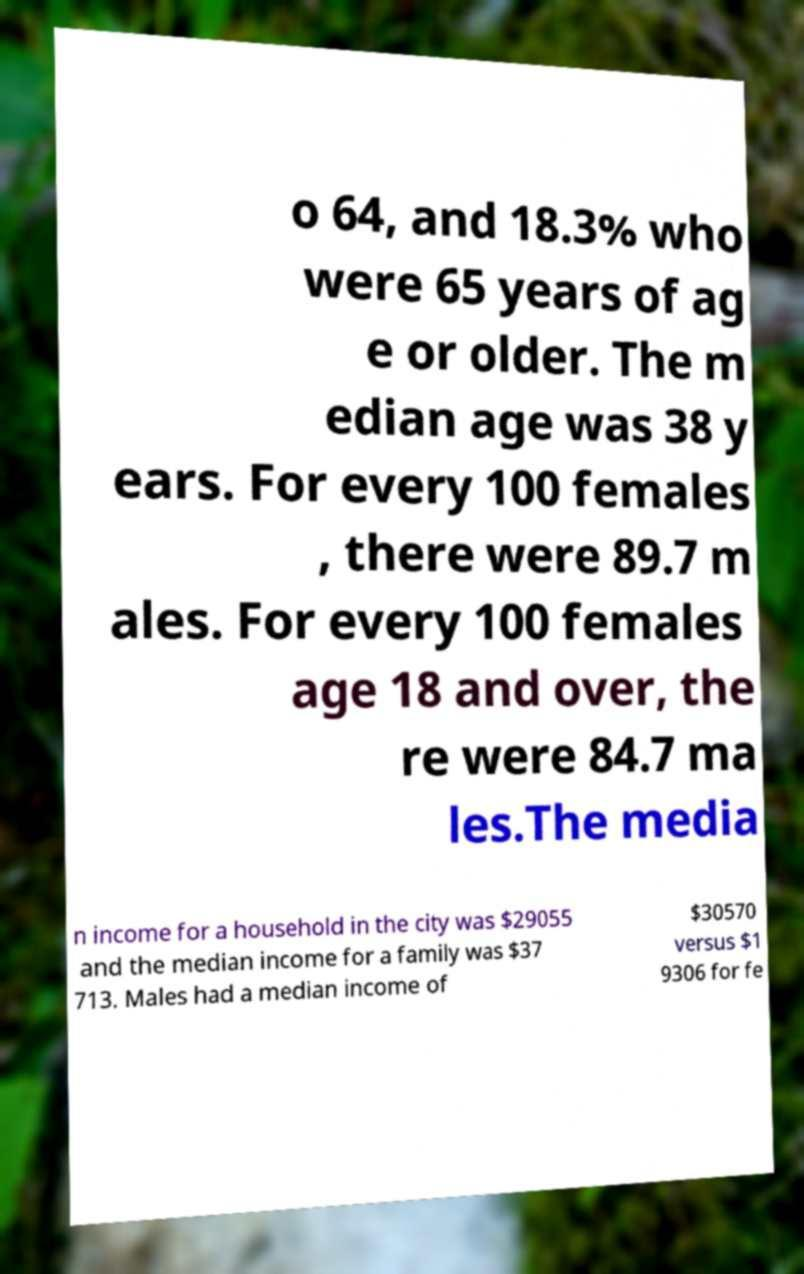For documentation purposes, I need the text within this image transcribed. Could you provide that? o 64, and 18.3% who were 65 years of ag e or older. The m edian age was 38 y ears. For every 100 females , there were 89.7 m ales. For every 100 females age 18 and over, the re were 84.7 ma les.The media n income for a household in the city was $29055 and the median income for a family was $37 713. Males had a median income of $30570 versus $1 9306 for fe 